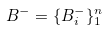Convert formula to latex. <formula><loc_0><loc_0><loc_500><loc_500>B ^ { - } = \{ B _ { i } ^ { - } \} _ { 1 } ^ { n }</formula> 